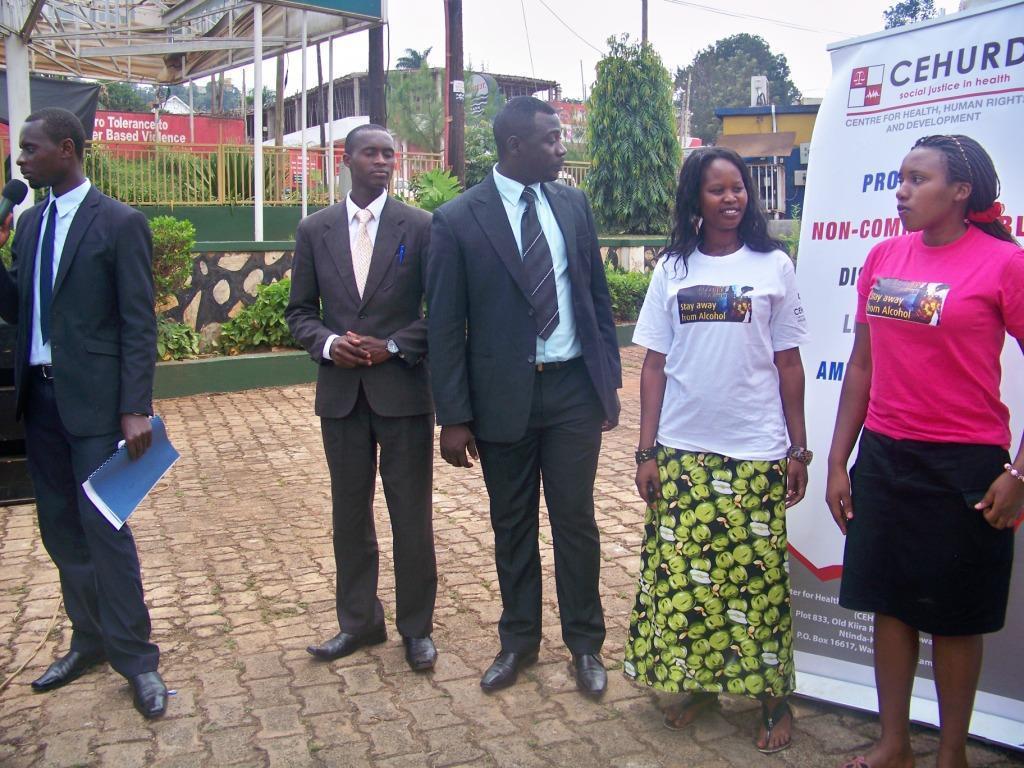Describe this image in one or two sentences. Here in this picture we can see a group of people standing on the ground, as we can see three men are wearing suits on them and the person on the left side is speaking something in the microphone present in his hand and he is also holding a file in his hand and the woman in the middle is smiling and behind them we can see a banner present and we can also see bushes, plants and trees on the ground and on the left side we can see a shed also present and in the far we can see some poles and stores present and we can see the sky is cloudy. 